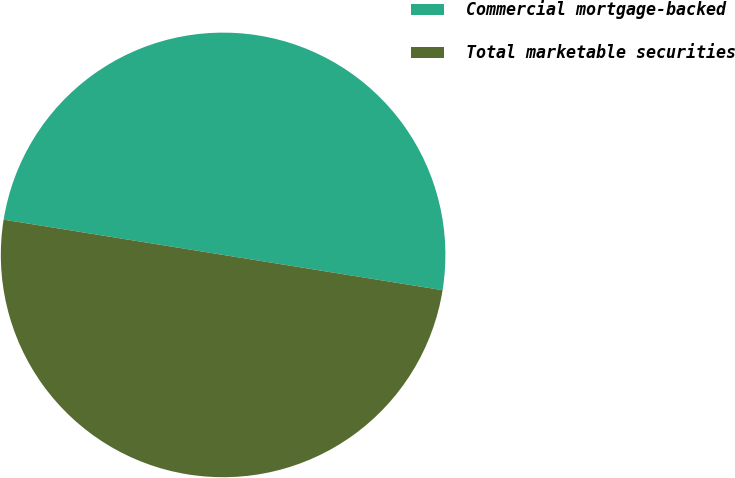<chart> <loc_0><loc_0><loc_500><loc_500><pie_chart><fcel>Commercial mortgage-backed<fcel>Total marketable securities<nl><fcel>50.0%<fcel>50.0%<nl></chart> 